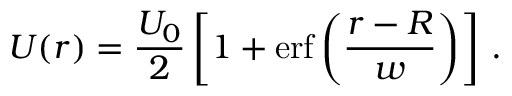Convert formula to latex. <formula><loc_0><loc_0><loc_500><loc_500>U ( r ) = \frac { U _ { 0 } } { 2 } \left [ 1 + e r f \left ( \frac { r - R } { w } \right ) \right ] \, .</formula> 